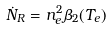<formula> <loc_0><loc_0><loc_500><loc_500>\dot { N } _ { R } = n _ { e } ^ { 2 } \beta _ { 2 } ( T _ { e } )</formula> 